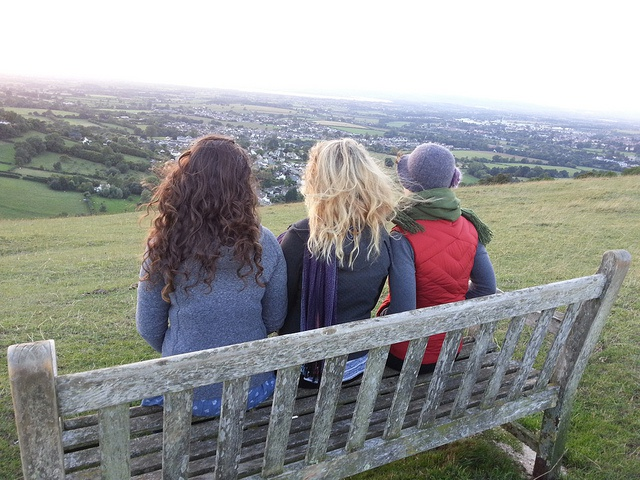Describe the objects in this image and their specific colors. I can see bench in white, gray, darkgray, and black tones, people in white, gray, black, and darkgray tones, people in white, black, navy, darkgray, and gray tones, and people in white, gray, darkgray, brown, and maroon tones in this image. 